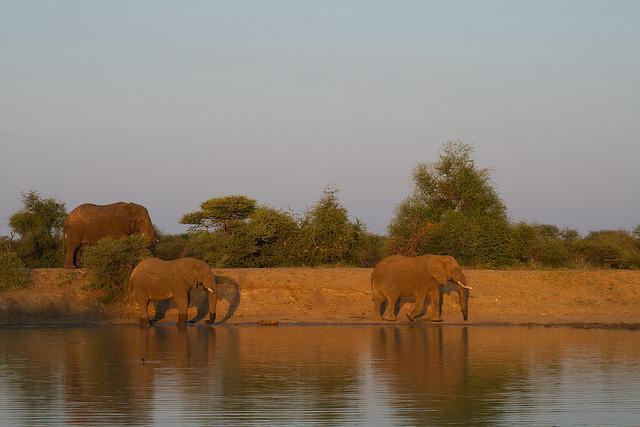How many animals in this scene?
Give a very brief answer. 3. How many elephants are there?
Give a very brief answer. 3. How many different clocks are there?
Give a very brief answer. 0. 